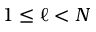<formula> <loc_0><loc_0><loc_500><loc_500>1 \leq \ell < N</formula> 